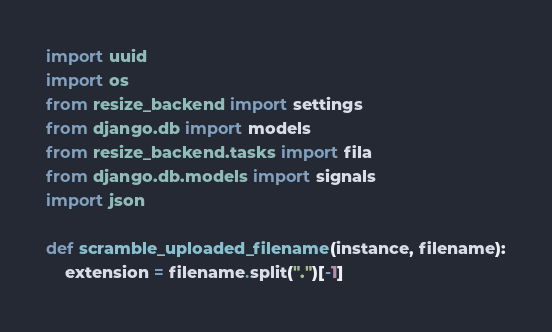<code> <loc_0><loc_0><loc_500><loc_500><_Python_>import uuid
import os
from resize_backend import settings
from django.db import models
from resize_backend.tasks import fila
from django.db.models import signals
import json

def scramble_uploaded_filename(instance, filename):
    extension = filename.split(".")[-1]</code> 